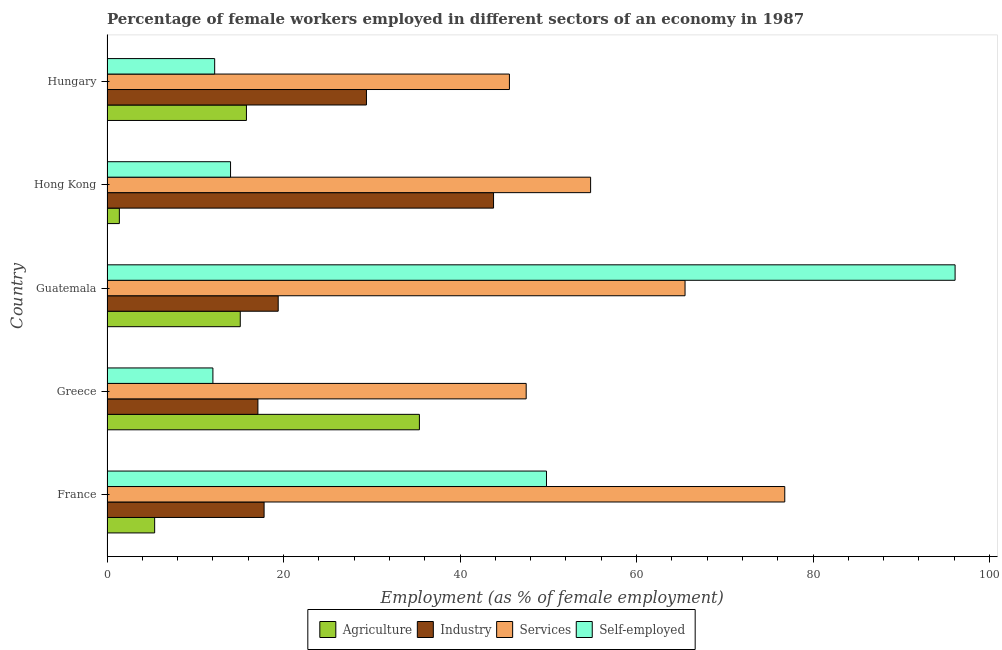How many bars are there on the 2nd tick from the bottom?
Offer a terse response. 4. What is the label of the 1st group of bars from the top?
Provide a short and direct response. Hungary. What is the percentage of female workers in industry in Hong Kong?
Ensure brevity in your answer.  43.8. Across all countries, what is the maximum percentage of self employed female workers?
Your response must be concise. 96.1. Across all countries, what is the minimum percentage of self employed female workers?
Provide a short and direct response. 12. In which country was the percentage of self employed female workers maximum?
Provide a short and direct response. Guatemala. In which country was the percentage of self employed female workers minimum?
Provide a short and direct response. Greece. What is the total percentage of female workers in industry in the graph?
Make the answer very short. 127.5. What is the difference between the percentage of female workers in industry in France and that in Greece?
Provide a succinct answer. 0.7. What is the difference between the percentage of female workers in industry in Guatemala and the percentage of female workers in services in Hungary?
Offer a very short reply. -26.2. What is the average percentage of female workers in agriculture per country?
Make the answer very short. 14.62. What is the ratio of the percentage of female workers in agriculture in France to that in Greece?
Offer a terse response. 0.15. Is the difference between the percentage of female workers in services in France and Hungary greater than the difference between the percentage of female workers in agriculture in France and Hungary?
Make the answer very short. Yes. What is the difference between the highest and the lowest percentage of female workers in agriculture?
Offer a terse response. 34. In how many countries, is the percentage of female workers in industry greater than the average percentage of female workers in industry taken over all countries?
Offer a terse response. 2. Is the sum of the percentage of female workers in services in France and Hong Kong greater than the maximum percentage of female workers in industry across all countries?
Make the answer very short. Yes. What does the 4th bar from the top in Hong Kong represents?
Provide a succinct answer. Agriculture. What does the 2nd bar from the bottom in Greece represents?
Make the answer very short. Industry. Is it the case that in every country, the sum of the percentage of female workers in agriculture and percentage of female workers in industry is greater than the percentage of female workers in services?
Your answer should be very brief. No. How many countries are there in the graph?
Your answer should be compact. 5. Are the values on the major ticks of X-axis written in scientific E-notation?
Your answer should be compact. No. Where does the legend appear in the graph?
Provide a succinct answer. Bottom center. How are the legend labels stacked?
Provide a short and direct response. Horizontal. What is the title of the graph?
Offer a terse response. Percentage of female workers employed in different sectors of an economy in 1987. Does "Energy" appear as one of the legend labels in the graph?
Offer a very short reply. No. What is the label or title of the X-axis?
Make the answer very short. Employment (as % of female employment). What is the label or title of the Y-axis?
Your answer should be compact. Country. What is the Employment (as % of female employment) in Agriculture in France?
Offer a terse response. 5.4. What is the Employment (as % of female employment) in Industry in France?
Your answer should be very brief. 17.8. What is the Employment (as % of female employment) of Services in France?
Keep it short and to the point. 76.8. What is the Employment (as % of female employment) of Self-employed in France?
Keep it short and to the point. 49.8. What is the Employment (as % of female employment) of Agriculture in Greece?
Keep it short and to the point. 35.4. What is the Employment (as % of female employment) of Industry in Greece?
Your answer should be very brief. 17.1. What is the Employment (as % of female employment) in Services in Greece?
Your answer should be very brief. 47.5. What is the Employment (as % of female employment) in Agriculture in Guatemala?
Ensure brevity in your answer.  15.1. What is the Employment (as % of female employment) in Industry in Guatemala?
Offer a very short reply. 19.4. What is the Employment (as % of female employment) of Services in Guatemala?
Give a very brief answer. 65.5. What is the Employment (as % of female employment) in Self-employed in Guatemala?
Make the answer very short. 96.1. What is the Employment (as % of female employment) of Agriculture in Hong Kong?
Offer a terse response. 1.4. What is the Employment (as % of female employment) in Industry in Hong Kong?
Keep it short and to the point. 43.8. What is the Employment (as % of female employment) in Services in Hong Kong?
Your answer should be very brief. 54.8. What is the Employment (as % of female employment) of Agriculture in Hungary?
Your answer should be compact. 15.8. What is the Employment (as % of female employment) in Industry in Hungary?
Make the answer very short. 29.4. What is the Employment (as % of female employment) of Services in Hungary?
Give a very brief answer. 45.6. What is the Employment (as % of female employment) of Self-employed in Hungary?
Provide a short and direct response. 12.2. Across all countries, what is the maximum Employment (as % of female employment) of Agriculture?
Provide a succinct answer. 35.4. Across all countries, what is the maximum Employment (as % of female employment) of Industry?
Your response must be concise. 43.8. Across all countries, what is the maximum Employment (as % of female employment) of Services?
Make the answer very short. 76.8. Across all countries, what is the maximum Employment (as % of female employment) of Self-employed?
Ensure brevity in your answer.  96.1. Across all countries, what is the minimum Employment (as % of female employment) in Agriculture?
Offer a very short reply. 1.4. Across all countries, what is the minimum Employment (as % of female employment) in Industry?
Provide a short and direct response. 17.1. Across all countries, what is the minimum Employment (as % of female employment) in Services?
Give a very brief answer. 45.6. Across all countries, what is the minimum Employment (as % of female employment) in Self-employed?
Give a very brief answer. 12. What is the total Employment (as % of female employment) of Agriculture in the graph?
Your response must be concise. 73.1. What is the total Employment (as % of female employment) of Industry in the graph?
Provide a short and direct response. 127.5. What is the total Employment (as % of female employment) of Services in the graph?
Provide a short and direct response. 290.2. What is the total Employment (as % of female employment) in Self-employed in the graph?
Your answer should be very brief. 184.1. What is the difference between the Employment (as % of female employment) of Services in France and that in Greece?
Keep it short and to the point. 29.3. What is the difference between the Employment (as % of female employment) in Self-employed in France and that in Greece?
Ensure brevity in your answer.  37.8. What is the difference between the Employment (as % of female employment) of Services in France and that in Guatemala?
Give a very brief answer. 11.3. What is the difference between the Employment (as % of female employment) of Self-employed in France and that in Guatemala?
Your answer should be very brief. -46.3. What is the difference between the Employment (as % of female employment) of Services in France and that in Hong Kong?
Provide a succinct answer. 22. What is the difference between the Employment (as % of female employment) of Self-employed in France and that in Hong Kong?
Your answer should be very brief. 35.8. What is the difference between the Employment (as % of female employment) in Agriculture in France and that in Hungary?
Ensure brevity in your answer.  -10.4. What is the difference between the Employment (as % of female employment) of Industry in France and that in Hungary?
Make the answer very short. -11.6. What is the difference between the Employment (as % of female employment) in Services in France and that in Hungary?
Ensure brevity in your answer.  31.2. What is the difference between the Employment (as % of female employment) in Self-employed in France and that in Hungary?
Ensure brevity in your answer.  37.6. What is the difference between the Employment (as % of female employment) in Agriculture in Greece and that in Guatemala?
Your response must be concise. 20.3. What is the difference between the Employment (as % of female employment) of Industry in Greece and that in Guatemala?
Give a very brief answer. -2.3. What is the difference between the Employment (as % of female employment) of Services in Greece and that in Guatemala?
Provide a succinct answer. -18. What is the difference between the Employment (as % of female employment) of Self-employed in Greece and that in Guatemala?
Your answer should be very brief. -84.1. What is the difference between the Employment (as % of female employment) in Agriculture in Greece and that in Hong Kong?
Provide a short and direct response. 34. What is the difference between the Employment (as % of female employment) of Industry in Greece and that in Hong Kong?
Keep it short and to the point. -26.7. What is the difference between the Employment (as % of female employment) of Services in Greece and that in Hong Kong?
Make the answer very short. -7.3. What is the difference between the Employment (as % of female employment) of Self-employed in Greece and that in Hong Kong?
Make the answer very short. -2. What is the difference between the Employment (as % of female employment) in Agriculture in Greece and that in Hungary?
Your answer should be very brief. 19.6. What is the difference between the Employment (as % of female employment) in Agriculture in Guatemala and that in Hong Kong?
Provide a succinct answer. 13.7. What is the difference between the Employment (as % of female employment) in Industry in Guatemala and that in Hong Kong?
Keep it short and to the point. -24.4. What is the difference between the Employment (as % of female employment) of Self-employed in Guatemala and that in Hong Kong?
Your answer should be very brief. 82.1. What is the difference between the Employment (as % of female employment) in Services in Guatemala and that in Hungary?
Offer a terse response. 19.9. What is the difference between the Employment (as % of female employment) of Self-employed in Guatemala and that in Hungary?
Keep it short and to the point. 83.9. What is the difference between the Employment (as % of female employment) in Agriculture in Hong Kong and that in Hungary?
Make the answer very short. -14.4. What is the difference between the Employment (as % of female employment) in Agriculture in France and the Employment (as % of female employment) in Services in Greece?
Your answer should be very brief. -42.1. What is the difference between the Employment (as % of female employment) of Agriculture in France and the Employment (as % of female employment) of Self-employed in Greece?
Offer a very short reply. -6.6. What is the difference between the Employment (as % of female employment) in Industry in France and the Employment (as % of female employment) in Services in Greece?
Keep it short and to the point. -29.7. What is the difference between the Employment (as % of female employment) of Services in France and the Employment (as % of female employment) of Self-employed in Greece?
Provide a succinct answer. 64.8. What is the difference between the Employment (as % of female employment) of Agriculture in France and the Employment (as % of female employment) of Industry in Guatemala?
Make the answer very short. -14. What is the difference between the Employment (as % of female employment) of Agriculture in France and the Employment (as % of female employment) of Services in Guatemala?
Your answer should be very brief. -60.1. What is the difference between the Employment (as % of female employment) in Agriculture in France and the Employment (as % of female employment) in Self-employed in Guatemala?
Provide a short and direct response. -90.7. What is the difference between the Employment (as % of female employment) in Industry in France and the Employment (as % of female employment) in Services in Guatemala?
Your response must be concise. -47.7. What is the difference between the Employment (as % of female employment) in Industry in France and the Employment (as % of female employment) in Self-employed in Guatemala?
Make the answer very short. -78.3. What is the difference between the Employment (as % of female employment) of Services in France and the Employment (as % of female employment) of Self-employed in Guatemala?
Offer a very short reply. -19.3. What is the difference between the Employment (as % of female employment) of Agriculture in France and the Employment (as % of female employment) of Industry in Hong Kong?
Provide a succinct answer. -38.4. What is the difference between the Employment (as % of female employment) of Agriculture in France and the Employment (as % of female employment) of Services in Hong Kong?
Give a very brief answer. -49.4. What is the difference between the Employment (as % of female employment) in Agriculture in France and the Employment (as % of female employment) in Self-employed in Hong Kong?
Offer a very short reply. -8.6. What is the difference between the Employment (as % of female employment) in Industry in France and the Employment (as % of female employment) in Services in Hong Kong?
Your answer should be compact. -37. What is the difference between the Employment (as % of female employment) in Services in France and the Employment (as % of female employment) in Self-employed in Hong Kong?
Ensure brevity in your answer.  62.8. What is the difference between the Employment (as % of female employment) of Agriculture in France and the Employment (as % of female employment) of Services in Hungary?
Offer a very short reply. -40.2. What is the difference between the Employment (as % of female employment) in Industry in France and the Employment (as % of female employment) in Services in Hungary?
Your answer should be compact. -27.8. What is the difference between the Employment (as % of female employment) of Services in France and the Employment (as % of female employment) of Self-employed in Hungary?
Offer a very short reply. 64.6. What is the difference between the Employment (as % of female employment) of Agriculture in Greece and the Employment (as % of female employment) of Services in Guatemala?
Give a very brief answer. -30.1. What is the difference between the Employment (as % of female employment) in Agriculture in Greece and the Employment (as % of female employment) in Self-employed in Guatemala?
Your response must be concise. -60.7. What is the difference between the Employment (as % of female employment) in Industry in Greece and the Employment (as % of female employment) in Services in Guatemala?
Your answer should be very brief. -48.4. What is the difference between the Employment (as % of female employment) in Industry in Greece and the Employment (as % of female employment) in Self-employed in Guatemala?
Ensure brevity in your answer.  -79. What is the difference between the Employment (as % of female employment) of Services in Greece and the Employment (as % of female employment) of Self-employed in Guatemala?
Keep it short and to the point. -48.6. What is the difference between the Employment (as % of female employment) of Agriculture in Greece and the Employment (as % of female employment) of Industry in Hong Kong?
Offer a very short reply. -8.4. What is the difference between the Employment (as % of female employment) in Agriculture in Greece and the Employment (as % of female employment) in Services in Hong Kong?
Provide a short and direct response. -19.4. What is the difference between the Employment (as % of female employment) of Agriculture in Greece and the Employment (as % of female employment) of Self-employed in Hong Kong?
Your answer should be compact. 21.4. What is the difference between the Employment (as % of female employment) in Industry in Greece and the Employment (as % of female employment) in Services in Hong Kong?
Make the answer very short. -37.7. What is the difference between the Employment (as % of female employment) in Services in Greece and the Employment (as % of female employment) in Self-employed in Hong Kong?
Provide a succinct answer. 33.5. What is the difference between the Employment (as % of female employment) in Agriculture in Greece and the Employment (as % of female employment) in Services in Hungary?
Give a very brief answer. -10.2. What is the difference between the Employment (as % of female employment) of Agriculture in Greece and the Employment (as % of female employment) of Self-employed in Hungary?
Give a very brief answer. 23.2. What is the difference between the Employment (as % of female employment) in Industry in Greece and the Employment (as % of female employment) in Services in Hungary?
Give a very brief answer. -28.5. What is the difference between the Employment (as % of female employment) of Services in Greece and the Employment (as % of female employment) of Self-employed in Hungary?
Offer a very short reply. 35.3. What is the difference between the Employment (as % of female employment) of Agriculture in Guatemala and the Employment (as % of female employment) of Industry in Hong Kong?
Keep it short and to the point. -28.7. What is the difference between the Employment (as % of female employment) of Agriculture in Guatemala and the Employment (as % of female employment) of Services in Hong Kong?
Offer a terse response. -39.7. What is the difference between the Employment (as % of female employment) in Industry in Guatemala and the Employment (as % of female employment) in Services in Hong Kong?
Make the answer very short. -35.4. What is the difference between the Employment (as % of female employment) of Services in Guatemala and the Employment (as % of female employment) of Self-employed in Hong Kong?
Keep it short and to the point. 51.5. What is the difference between the Employment (as % of female employment) in Agriculture in Guatemala and the Employment (as % of female employment) in Industry in Hungary?
Provide a short and direct response. -14.3. What is the difference between the Employment (as % of female employment) in Agriculture in Guatemala and the Employment (as % of female employment) in Services in Hungary?
Your answer should be compact. -30.5. What is the difference between the Employment (as % of female employment) of Agriculture in Guatemala and the Employment (as % of female employment) of Self-employed in Hungary?
Provide a succinct answer. 2.9. What is the difference between the Employment (as % of female employment) of Industry in Guatemala and the Employment (as % of female employment) of Services in Hungary?
Ensure brevity in your answer.  -26.2. What is the difference between the Employment (as % of female employment) in Services in Guatemala and the Employment (as % of female employment) in Self-employed in Hungary?
Give a very brief answer. 53.3. What is the difference between the Employment (as % of female employment) of Agriculture in Hong Kong and the Employment (as % of female employment) of Services in Hungary?
Give a very brief answer. -44.2. What is the difference between the Employment (as % of female employment) of Agriculture in Hong Kong and the Employment (as % of female employment) of Self-employed in Hungary?
Provide a succinct answer. -10.8. What is the difference between the Employment (as % of female employment) in Industry in Hong Kong and the Employment (as % of female employment) in Services in Hungary?
Your answer should be compact. -1.8. What is the difference between the Employment (as % of female employment) of Industry in Hong Kong and the Employment (as % of female employment) of Self-employed in Hungary?
Your answer should be very brief. 31.6. What is the difference between the Employment (as % of female employment) in Services in Hong Kong and the Employment (as % of female employment) in Self-employed in Hungary?
Keep it short and to the point. 42.6. What is the average Employment (as % of female employment) of Agriculture per country?
Your answer should be compact. 14.62. What is the average Employment (as % of female employment) of Services per country?
Make the answer very short. 58.04. What is the average Employment (as % of female employment) of Self-employed per country?
Provide a succinct answer. 36.82. What is the difference between the Employment (as % of female employment) of Agriculture and Employment (as % of female employment) of Industry in France?
Offer a very short reply. -12.4. What is the difference between the Employment (as % of female employment) of Agriculture and Employment (as % of female employment) of Services in France?
Your response must be concise. -71.4. What is the difference between the Employment (as % of female employment) in Agriculture and Employment (as % of female employment) in Self-employed in France?
Provide a succinct answer. -44.4. What is the difference between the Employment (as % of female employment) of Industry and Employment (as % of female employment) of Services in France?
Make the answer very short. -59. What is the difference between the Employment (as % of female employment) in Industry and Employment (as % of female employment) in Self-employed in France?
Provide a short and direct response. -32. What is the difference between the Employment (as % of female employment) in Agriculture and Employment (as % of female employment) in Self-employed in Greece?
Keep it short and to the point. 23.4. What is the difference between the Employment (as % of female employment) of Industry and Employment (as % of female employment) of Services in Greece?
Offer a very short reply. -30.4. What is the difference between the Employment (as % of female employment) of Industry and Employment (as % of female employment) of Self-employed in Greece?
Your answer should be very brief. 5.1. What is the difference between the Employment (as % of female employment) of Services and Employment (as % of female employment) of Self-employed in Greece?
Your answer should be very brief. 35.5. What is the difference between the Employment (as % of female employment) of Agriculture and Employment (as % of female employment) of Industry in Guatemala?
Your answer should be compact. -4.3. What is the difference between the Employment (as % of female employment) in Agriculture and Employment (as % of female employment) in Services in Guatemala?
Ensure brevity in your answer.  -50.4. What is the difference between the Employment (as % of female employment) in Agriculture and Employment (as % of female employment) in Self-employed in Guatemala?
Provide a succinct answer. -81. What is the difference between the Employment (as % of female employment) in Industry and Employment (as % of female employment) in Services in Guatemala?
Give a very brief answer. -46.1. What is the difference between the Employment (as % of female employment) in Industry and Employment (as % of female employment) in Self-employed in Guatemala?
Your answer should be very brief. -76.7. What is the difference between the Employment (as % of female employment) in Services and Employment (as % of female employment) in Self-employed in Guatemala?
Your answer should be compact. -30.6. What is the difference between the Employment (as % of female employment) in Agriculture and Employment (as % of female employment) in Industry in Hong Kong?
Ensure brevity in your answer.  -42.4. What is the difference between the Employment (as % of female employment) of Agriculture and Employment (as % of female employment) of Services in Hong Kong?
Provide a succinct answer. -53.4. What is the difference between the Employment (as % of female employment) in Industry and Employment (as % of female employment) in Services in Hong Kong?
Your response must be concise. -11. What is the difference between the Employment (as % of female employment) of Industry and Employment (as % of female employment) of Self-employed in Hong Kong?
Give a very brief answer. 29.8. What is the difference between the Employment (as % of female employment) in Services and Employment (as % of female employment) in Self-employed in Hong Kong?
Offer a very short reply. 40.8. What is the difference between the Employment (as % of female employment) of Agriculture and Employment (as % of female employment) of Industry in Hungary?
Offer a terse response. -13.6. What is the difference between the Employment (as % of female employment) in Agriculture and Employment (as % of female employment) in Services in Hungary?
Ensure brevity in your answer.  -29.8. What is the difference between the Employment (as % of female employment) of Industry and Employment (as % of female employment) of Services in Hungary?
Make the answer very short. -16.2. What is the difference between the Employment (as % of female employment) in Services and Employment (as % of female employment) in Self-employed in Hungary?
Make the answer very short. 33.4. What is the ratio of the Employment (as % of female employment) in Agriculture in France to that in Greece?
Offer a terse response. 0.15. What is the ratio of the Employment (as % of female employment) in Industry in France to that in Greece?
Provide a succinct answer. 1.04. What is the ratio of the Employment (as % of female employment) in Services in France to that in Greece?
Your answer should be compact. 1.62. What is the ratio of the Employment (as % of female employment) of Self-employed in France to that in Greece?
Your answer should be very brief. 4.15. What is the ratio of the Employment (as % of female employment) of Agriculture in France to that in Guatemala?
Provide a succinct answer. 0.36. What is the ratio of the Employment (as % of female employment) of Industry in France to that in Guatemala?
Your answer should be very brief. 0.92. What is the ratio of the Employment (as % of female employment) of Services in France to that in Guatemala?
Ensure brevity in your answer.  1.17. What is the ratio of the Employment (as % of female employment) of Self-employed in France to that in Guatemala?
Give a very brief answer. 0.52. What is the ratio of the Employment (as % of female employment) of Agriculture in France to that in Hong Kong?
Your answer should be compact. 3.86. What is the ratio of the Employment (as % of female employment) in Industry in France to that in Hong Kong?
Keep it short and to the point. 0.41. What is the ratio of the Employment (as % of female employment) in Services in France to that in Hong Kong?
Offer a very short reply. 1.4. What is the ratio of the Employment (as % of female employment) of Self-employed in France to that in Hong Kong?
Offer a very short reply. 3.56. What is the ratio of the Employment (as % of female employment) of Agriculture in France to that in Hungary?
Your answer should be compact. 0.34. What is the ratio of the Employment (as % of female employment) of Industry in France to that in Hungary?
Your answer should be very brief. 0.61. What is the ratio of the Employment (as % of female employment) of Services in France to that in Hungary?
Make the answer very short. 1.68. What is the ratio of the Employment (as % of female employment) of Self-employed in France to that in Hungary?
Your answer should be very brief. 4.08. What is the ratio of the Employment (as % of female employment) of Agriculture in Greece to that in Guatemala?
Give a very brief answer. 2.34. What is the ratio of the Employment (as % of female employment) in Industry in Greece to that in Guatemala?
Ensure brevity in your answer.  0.88. What is the ratio of the Employment (as % of female employment) of Services in Greece to that in Guatemala?
Your answer should be very brief. 0.73. What is the ratio of the Employment (as % of female employment) of Self-employed in Greece to that in Guatemala?
Make the answer very short. 0.12. What is the ratio of the Employment (as % of female employment) in Agriculture in Greece to that in Hong Kong?
Provide a succinct answer. 25.29. What is the ratio of the Employment (as % of female employment) in Industry in Greece to that in Hong Kong?
Provide a short and direct response. 0.39. What is the ratio of the Employment (as % of female employment) of Services in Greece to that in Hong Kong?
Ensure brevity in your answer.  0.87. What is the ratio of the Employment (as % of female employment) of Agriculture in Greece to that in Hungary?
Give a very brief answer. 2.24. What is the ratio of the Employment (as % of female employment) of Industry in Greece to that in Hungary?
Your answer should be very brief. 0.58. What is the ratio of the Employment (as % of female employment) in Services in Greece to that in Hungary?
Make the answer very short. 1.04. What is the ratio of the Employment (as % of female employment) of Self-employed in Greece to that in Hungary?
Your response must be concise. 0.98. What is the ratio of the Employment (as % of female employment) of Agriculture in Guatemala to that in Hong Kong?
Offer a terse response. 10.79. What is the ratio of the Employment (as % of female employment) in Industry in Guatemala to that in Hong Kong?
Your answer should be very brief. 0.44. What is the ratio of the Employment (as % of female employment) of Services in Guatemala to that in Hong Kong?
Your answer should be compact. 1.2. What is the ratio of the Employment (as % of female employment) of Self-employed in Guatemala to that in Hong Kong?
Your answer should be very brief. 6.86. What is the ratio of the Employment (as % of female employment) of Agriculture in Guatemala to that in Hungary?
Keep it short and to the point. 0.96. What is the ratio of the Employment (as % of female employment) of Industry in Guatemala to that in Hungary?
Keep it short and to the point. 0.66. What is the ratio of the Employment (as % of female employment) of Services in Guatemala to that in Hungary?
Your answer should be very brief. 1.44. What is the ratio of the Employment (as % of female employment) of Self-employed in Guatemala to that in Hungary?
Your answer should be compact. 7.88. What is the ratio of the Employment (as % of female employment) of Agriculture in Hong Kong to that in Hungary?
Your answer should be very brief. 0.09. What is the ratio of the Employment (as % of female employment) of Industry in Hong Kong to that in Hungary?
Give a very brief answer. 1.49. What is the ratio of the Employment (as % of female employment) in Services in Hong Kong to that in Hungary?
Your answer should be compact. 1.2. What is the ratio of the Employment (as % of female employment) in Self-employed in Hong Kong to that in Hungary?
Keep it short and to the point. 1.15. What is the difference between the highest and the second highest Employment (as % of female employment) of Agriculture?
Your answer should be compact. 19.6. What is the difference between the highest and the second highest Employment (as % of female employment) in Self-employed?
Offer a very short reply. 46.3. What is the difference between the highest and the lowest Employment (as % of female employment) in Agriculture?
Your response must be concise. 34. What is the difference between the highest and the lowest Employment (as % of female employment) in Industry?
Your answer should be very brief. 26.7. What is the difference between the highest and the lowest Employment (as % of female employment) of Services?
Your answer should be very brief. 31.2. What is the difference between the highest and the lowest Employment (as % of female employment) in Self-employed?
Offer a very short reply. 84.1. 